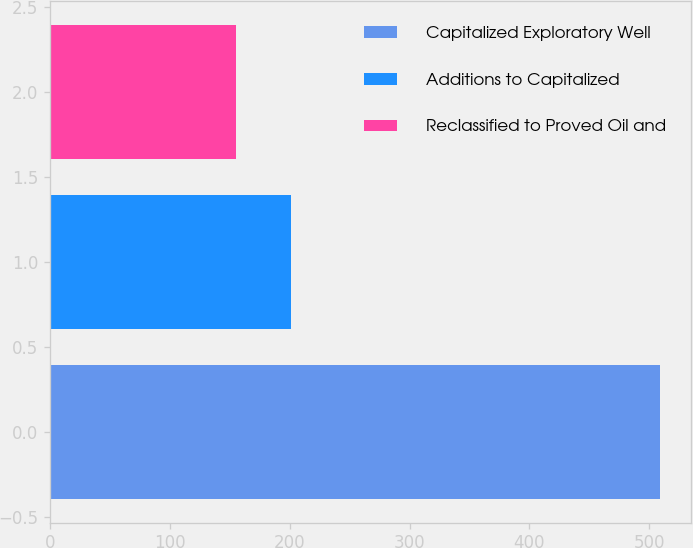<chart> <loc_0><loc_0><loc_500><loc_500><bar_chart><fcel>Capitalized Exploratory Well<fcel>Additions to Capitalized<fcel>Reclassified to Proved Oil and<nl><fcel>509.3<fcel>201.3<fcel>155<nl></chart> 